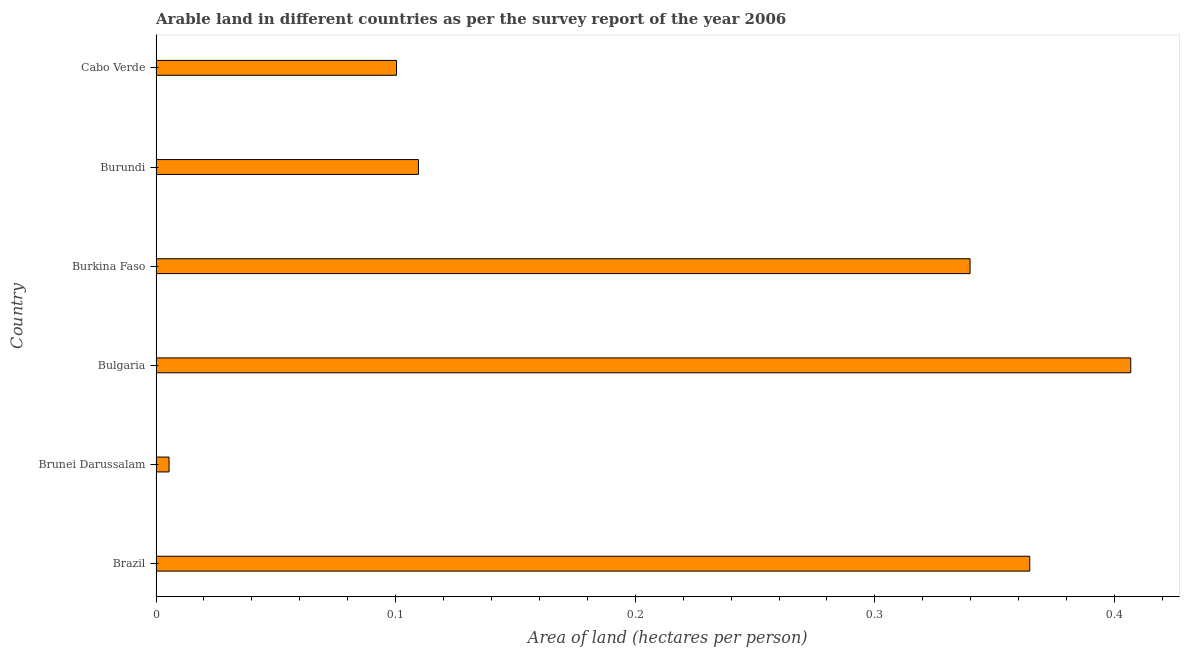What is the title of the graph?
Your response must be concise. Arable land in different countries as per the survey report of the year 2006. What is the label or title of the X-axis?
Your answer should be very brief. Area of land (hectares per person). What is the label or title of the Y-axis?
Provide a succinct answer. Country. What is the area of arable land in Brunei Darussalam?
Give a very brief answer. 0.01. Across all countries, what is the maximum area of arable land?
Provide a short and direct response. 0.41. Across all countries, what is the minimum area of arable land?
Your answer should be compact. 0.01. In which country was the area of arable land maximum?
Provide a short and direct response. Bulgaria. In which country was the area of arable land minimum?
Provide a succinct answer. Brunei Darussalam. What is the sum of the area of arable land?
Make the answer very short. 1.33. What is the difference between the area of arable land in Brazil and Bulgaria?
Provide a short and direct response. -0.04. What is the average area of arable land per country?
Give a very brief answer. 0.22. What is the median area of arable land?
Ensure brevity in your answer.  0.22. In how many countries, is the area of arable land greater than 0.04 hectares per person?
Your answer should be very brief. 5. What is the ratio of the area of arable land in Bulgaria to that in Cabo Verde?
Ensure brevity in your answer.  4.05. Is the area of arable land in Brazil less than that in Burkina Faso?
Your response must be concise. No. Is the difference between the area of arable land in Brunei Darussalam and Bulgaria greater than the difference between any two countries?
Offer a very short reply. Yes. What is the difference between the highest and the second highest area of arable land?
Offer a very short reply. 0.04. Is the sum of the area of arable land in Burkina Faso and Cabo Verde greater than the maximum area of arable land across all countries?
Offer a terse response. Yes. In how many countries, is the area of arable land greater than the average area of arable land taken over all countries?
Your response must be concise. 3. How many bars are there?
Give a very brief answer. 6. Are the values on the major ticks of X-axis written in scientific E-notation?
Your answer should be compact. No. What is the Area of land (hectares per person) of Brazil?
Your answer should be very brief. 0.36. What is the Area of land (hectares per person) in Brunei Darussalam?
Provide a succinct answer. 0.01. What is the Area of land (hectares per person) of Bulgaria?
Your answer should be very brief. 0.41. What is the Area of land (hectares per person) in Burkina Faso?
Keep it short and to the point. 0.34. What is the Area of land (hectares per person) in Burundi?
Ensure brevity in your answer.  0.11. What is the Area of land (hectares per person) in Cabo Verde?
Make the answer very short. 0.1. What is the difference between the Area of land (hectares per person) in Brazil and Brunei Darussalam?
Provide a short and direct response. 0.36. What is the difference between the Area of land (hectares per person) in Brazil and Bulgaria?
Provide a succinct answer. -0.04. What is the difference between the Area of land (hectares per person) in Brazil and Burkina Faso?
Your answer should be very brief. 0.02. What is the difference between the Area of land (hectares per person) in Brazil and Burundi?
Keep it short and to the point. 0.26. What is the difference between the Area of land (hectares per person) in Brazil and Cabo Verde?
Your response must be concise. 0.26. What is the difference between the Area of land (hectares per person) in Brunei Darussalam and Bulgaria?
Provide a succinct answer. -0.4. What is the difference between the Area of land (hectares per person) in Brunei Darussalam and Burkina Faso?
Keep it short and to the point. -0.33. What is the difference between the Area of land (hectares per person) in Brunei Darussalam and Burundi?
Provide a succinct answer. -0.1. What is the difference between the Area of land (hectares per person) in Brunei Darussalam and Cabo Verde?
Offer a terse response. -0.09. What is the difference between the Area of land (hectares per person) in Bulgaria and Burkina Faso?
Provide a succinct answer. 0.07. What is the difference between the Area of land (hectares per person) in Bulgaria and Burundi?
Offer a terse response. 0.3. What is the difference between the Area of land (hectares per person) in Bulgaria and Cabo Verde?
Provide a succinct answer. 0.31. What is the difference between the Area of land (hectares per person) in Burkina Faso and Burundi?
Keep it short and to the point. 0.23. What is the difference between the Area of land (hectares per person) in Burkina Faso and Cabo Verde?
Provide a succinct answer. 0.24. What is the difference between the Area of land (hectares per person) in Burundi and Cabo Verde?
Offer a very short reply. 0.01. What is the ratio of the Area of land (hectares per person) in Brazil to that in Brunei Darussalam?
Your answer should be compact. 67.12. What is the ratio of the Area of land (hectares per person) in Brazil to that in Bulgaria?
Give a very brief answer. 0.9. What is the ratio of the Area of land (hectares per person) in Brazil to that in Burkina Faso?
Ensure brevity in your answer.  1.07. What is the ratio of the Area of land (hectares per person) in Brazil to that in Burundi?
Keep it short and to the point. 3.33. What is the ratio of the Area of land (hectares per person) in Brazil to that in Cabo Verde?
Make the answer very short. 3.63. What is the ratio of the Area of land (hectares per person) in Brunei Darussalam to that in Bulgaria?
Offer a terse response. 0.01. What is the ratio of the Area of land (hectares per person) in Brunei Darussalam to that in Burkina Faso?
Keep it short and to the point. 0.02. What is the ratio of the Area of land (hectares per person) in Brunei Darussalam to that in Cabo Verde?
Your response must be concise. 0.05. What is the ratio of the Area of land (hectares per person) in Bulgaria to that in Burkina Faso?
Make the answer very short. 1.2. What is the ratio of the Area of land (hectares per person) in Bulgaria to that in Burundi?
Your response must be concise. 3.71. What is the ratio of the Area of land (hectares per person) in Bulgaria to that in Cabo Verde?
Ensure brevity in your answer.  4.05. What is the ratio of the Area of land (hectares per person) in Burkina Faso to that in Burundi?
Give a very brief answer. 3.1. What is the ratio of the Area of land (hectares per person) in Burkina Faso to that in Cabo Verde?
Keep it short and to the point. 3.38. What is the ratio of the Area of land (hectares per person) in Burundi to that in Cabo Verde?
Ensure brevity in your answer.  1.09. 